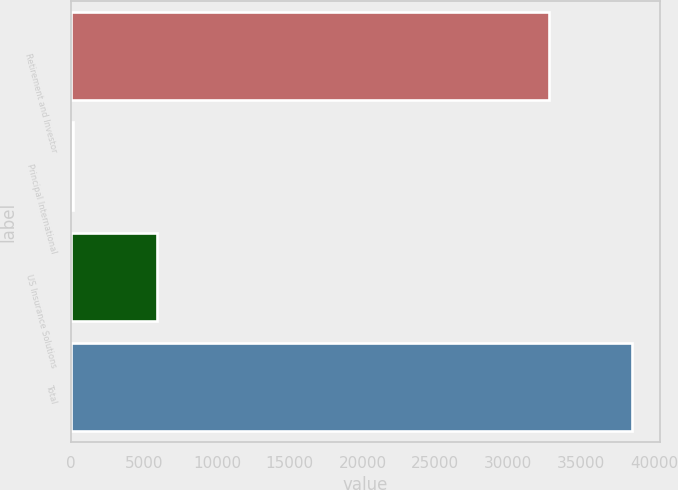<chart> <loc_0><loc_0><loc_500><loc_500><bar_chart><fcel>Retirement and Investor<fcel>Principal International<fcel>US Insurance Solutions<fcel>Total<nl><fcel>32801.4<fcel>108.5<fcel>5867.4<fcel>38502.9<nl></chart> 